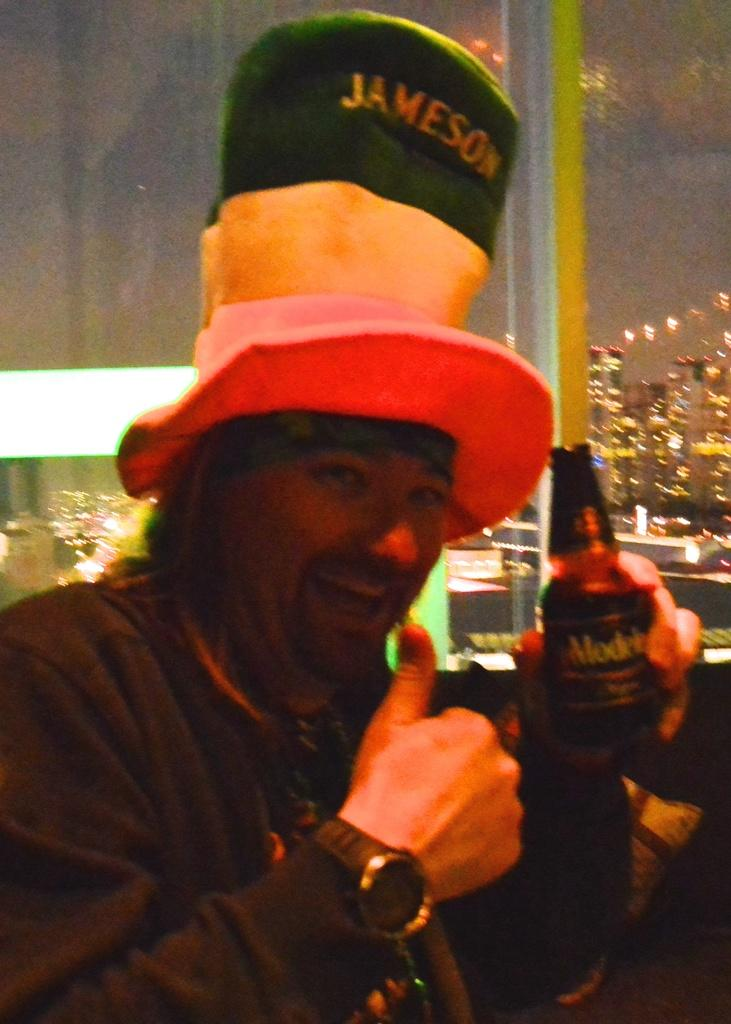Who is in the image? There is a man in the image. What is the man holding in the image? The man is holding a bottle. What is the man's facial expression in the image? The man has a smile on his face. What is the man wearing on his head in the image? The man is wearing a cap. What is written on the man's cap in the image? The cap has "Jameson" written on it. What month is it in the image? The month is not mentioned or depicted in the image. Is there a lake visible in the image? There is no lake present in the image. 